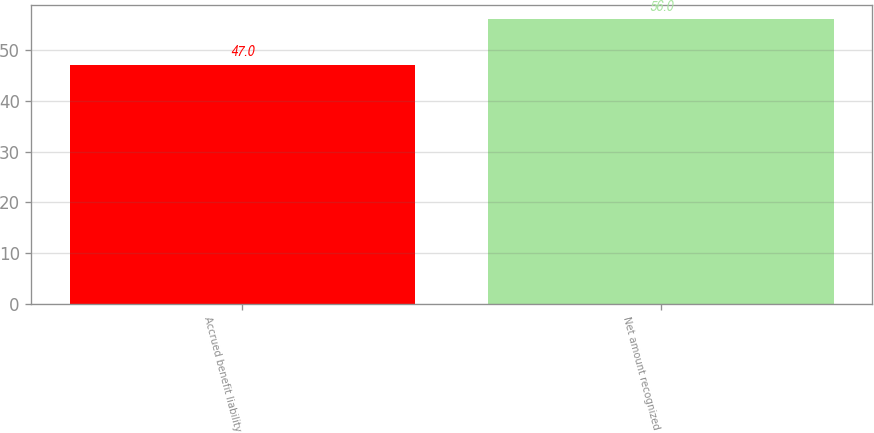Convert chart. <chart><loc_0><loc_0><loc_500><loc_500><bar_chart><fcel>Accrued benefit liability<fcel>Net amount recognized<nl><fcel>47<fcel>56<nl></chart> 